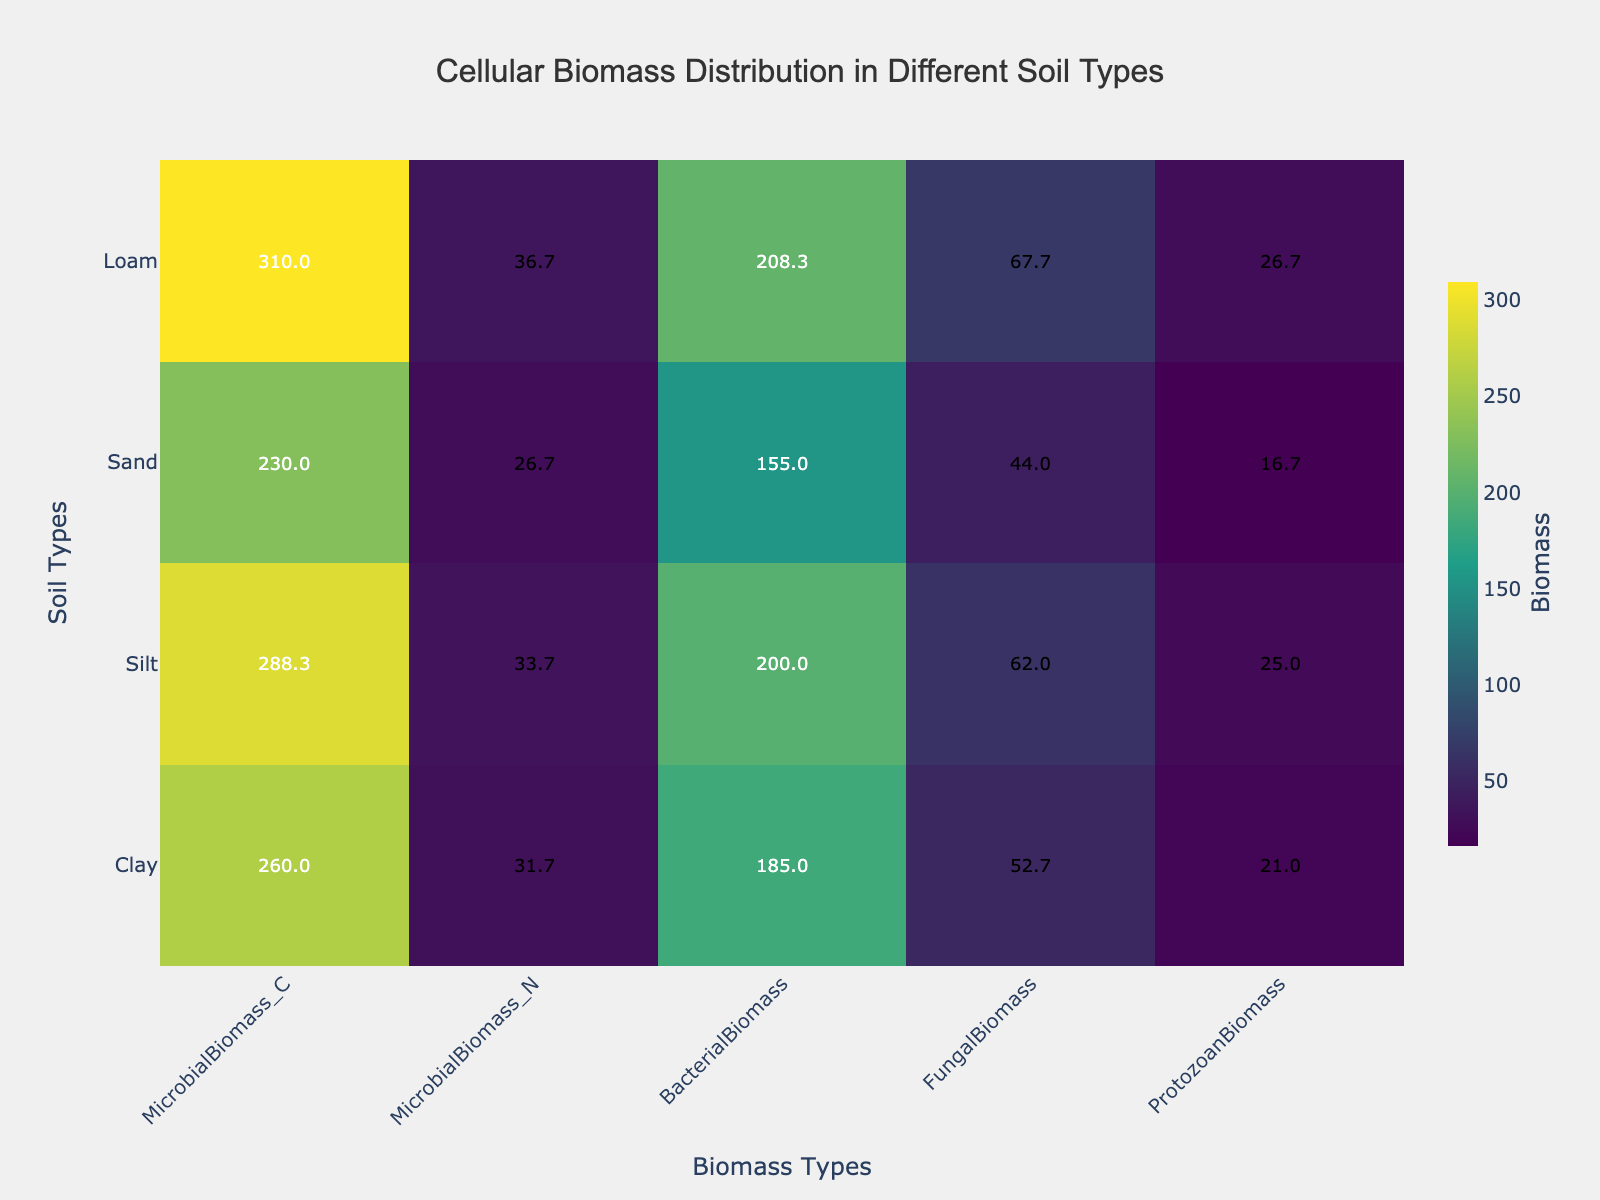What is the title of the heatmap? The title is located at the top of the heatmap. By reading it from the rendered figure, you can see it clearly.
Answer: Cellular Biomass Distribution in Different Soil Types What are the different soil types shown on the heatmap? The different soil types are listed on the y-axis of the heatmap.
Answer: Clay, Silt, Sand, Loam Which soil type shows the highest microbial biomass carbon (C)? Look at the column labeled "MicrobialBiomass_C" and identify the highest value. Then check the corresponding soil type on the y-axis.
Answer: Silt Which biomass type has the lowest average value across all soil types? Calculate the average value for each biomass type column and identify the smallest average.
Answer: ProtozoanBiomass What is the fungal biomass for loam soil? Find the intersection point of "Loam" on the y-axis and "FungalBiomass" on the x-axis and read the value from that cell.
Answer: 62 How does bacterial biomass in sandy soil compare to that in clay soil? Compare the values under "BacterialBiomass" for "Sand" and "Clay" rows.
Answer: Sand soil has lower bacterial biomass than clay soil What is the range of protozoan biomass values across all soil types? Identify the minimum and maximum values in the "ProtozoanBiomass" column and calculate their difference.
Answer: 28 - 15 = 13 Which soil type shows the greatest difference between fungal biomass and bacterial biomass? For each soil type, subtract the bacterial biomass from the fungal biomass and determine which soil type has the largest difference.
Answer: Silt Given the average microbial biomass nitrogen (N) for all soil types, which one is closest to the average? Compute the average "MicrobialBiomass_N" for all soil types and determine which soil type value is closest to this average.
Answer: Loam Which soil type has the most uniform distribution of biomass types, and how can you tell? The soil type with the most uniform distribution will have the smallest variance across different biomass types. Calculate the variance for each soil type's biomass values and find the lowest.
Answer: Loam 